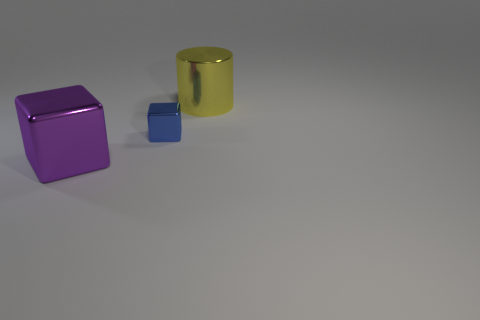The big shiny block is what color?
Provide a short and direct response. Purple. Is the number of shiny cylinders that are behind the small metal object greater than the number of yellow metal things that are left of the shiny cylinder?
Your response must be concise. Yes. There is a purple object; does it have the same shape as the small object that is behind the large purple object?
Offer a very short reply. Yes. There is a thing behind the blue cube; is its size the same as the shiny block behind the purple metallic thing?
Offer a terse response. No. Is there a large metal thing that is to the right of the blue metal object that is behind the large object left of the tiny shiny thing?
Keep it short and to the point. Yes. Are there fewer small blue cubes right of the small block than big purple metal blocks behind the big block?
Give a very brief answer. No. What is the shape of the big purple object that is the same material as the yellow thing?
Offer a terse response. Cube. What size is the cube that is to the left of the metallic block that is behind the block left of the small blue object?
Provide a succinct answer. Large. Are there more small green objects than big yellow shiny objects?
Your answer should be compact. No. What number of cylinders are the same size as the purple block?
Provide a succinct answer. 1. 